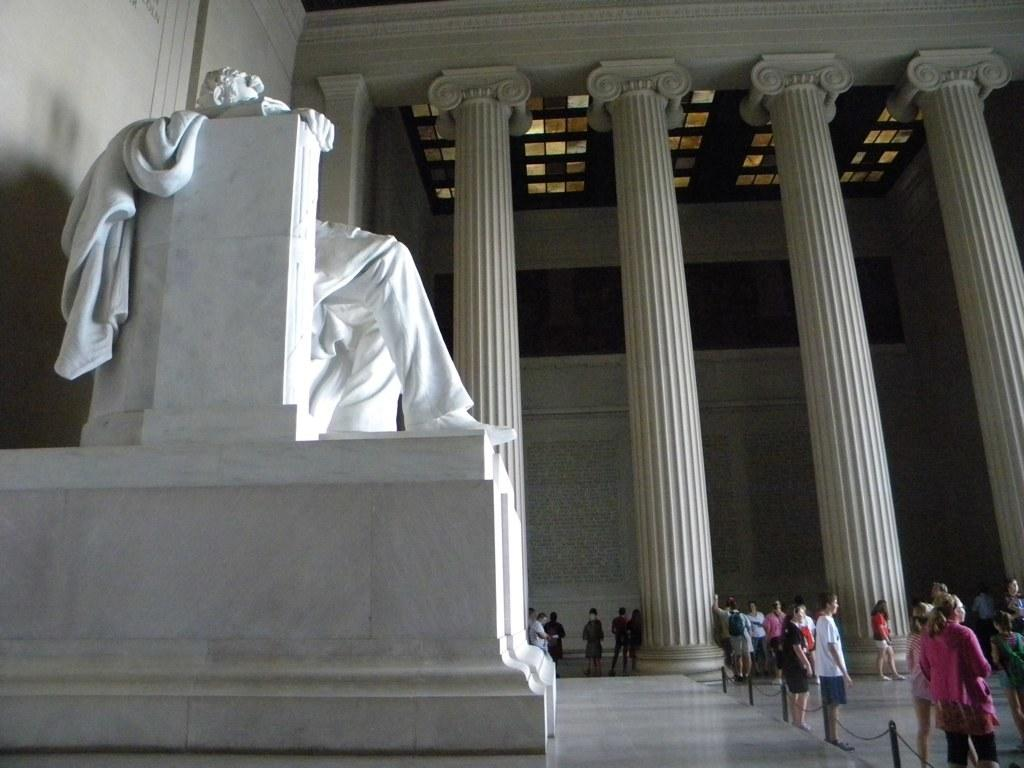What can be seen in the image involving people? There are persons standing in the image. What is another prominent feature in the image? There is a statue in the image. What is the color of the statue? The statue is white in color. What architectural elements can be seen in the background of the image? There are pillars in the background of the image. What is the color of the wall in the background? The wall in the background is white in color. What type of texture can be seen on the badge of the person in the image? There is no badge visible on any person in the image. What type of collar is the statue wearing in the image? The statue is not wearing a collar, as it is a statue and not a living being. 